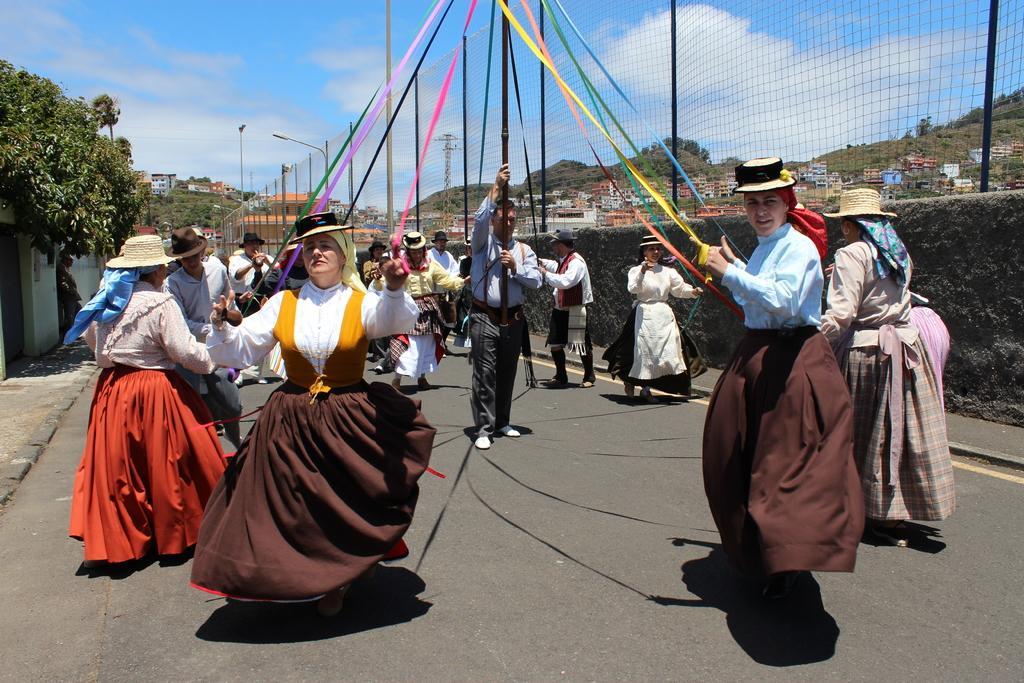Please provide a concise description of this image. In this picture, we can see a few people and a few are holding some objects, we can see the road, walls, trees, mountains, net, buildings, poles, lights and the sky with clouds. 